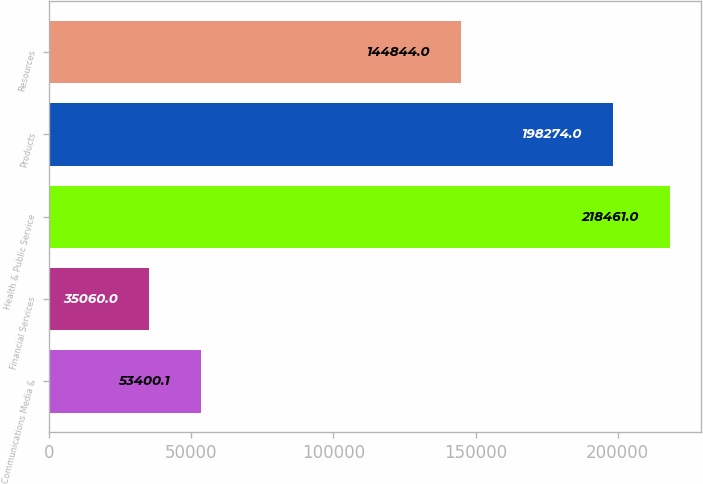Convert chart. <chart><loc_0><loc_0><loc_500><loc_500><bar_chart><fcel>Communications Media &<fcel>Financial Services<fcel>Health & Public Service<fcel>Products<fcel>Resources<nl><fcel>53400.1<fcel>35060<fcel>218461<fcel>198274<fcel>144844<nl></chart> 